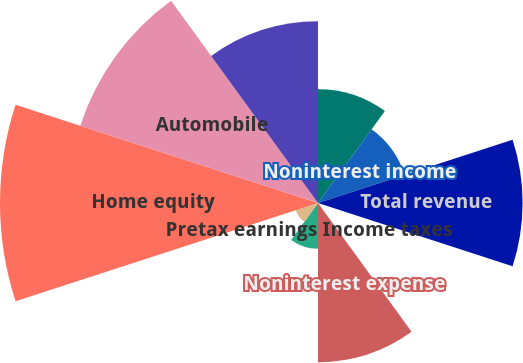Convert chart. <chart><loc_0><loc_0><loc_500><loc_500><pie_chart><fcel>Net interest income<fcel>Noninterest income<fcel>Total revenue<fcel>Provision for credit losses<fcel>Noninterest expense<fcel>Pretax earnings Income taxes<fcel>Earnings AVERAGE BALANCE SHEET<fcel>Home equity<fcel>Automobile<fcel>Education<nl><fcel>8.2%<fcel>6.57%<fcel>14.74%<fcel>0.03%<fcel>11.47%<fcel>3.3%<fcel>1.67%<fcel>22.91%<fcel>18.01%<fcel>13.1%<nl></chart> 